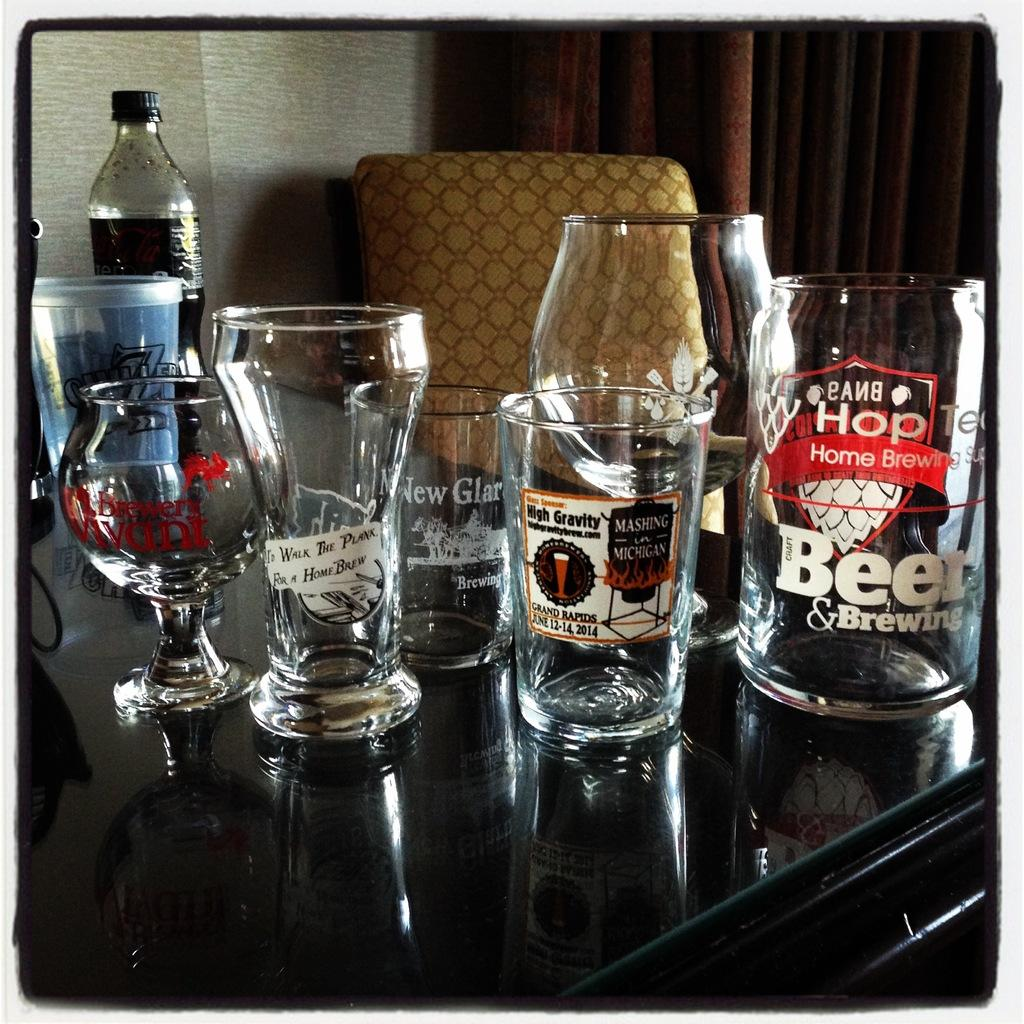What objects are on the table in the image? There are glasses, jars, and a bottle on the table in the image. What piece of furniture is located behind the table? There is a chair behind the table. What type of window treatment is present in the image? There is a curtain associated with the window. What color is the wall in the background of the image? There is a white wall in the background. What type of hill can be seen through the window in the image? There is no hill visible through the window in the image; it only shows a curtain and a white wall in the background. 